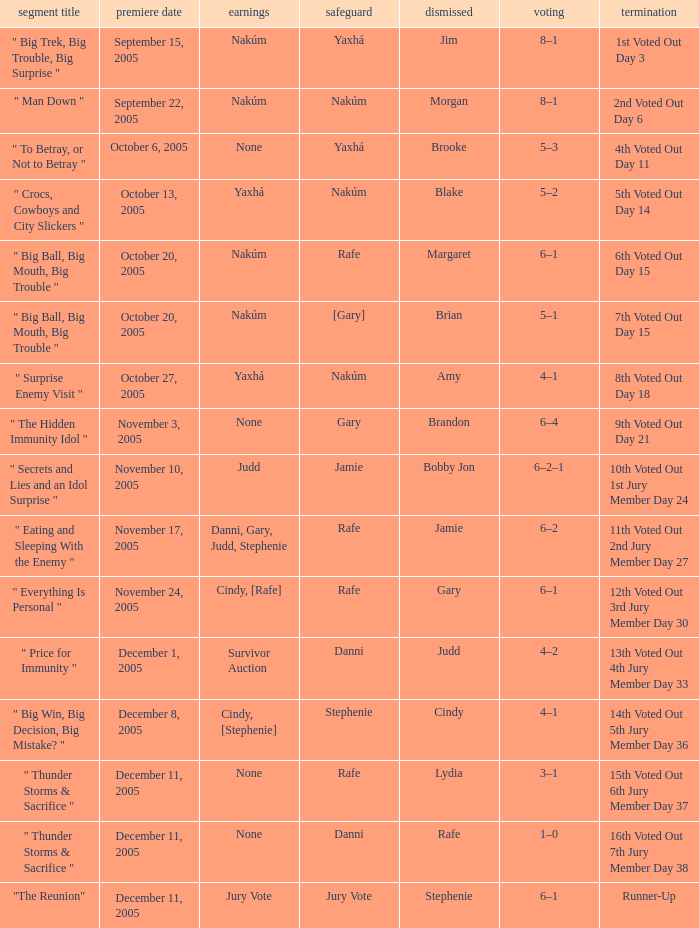What was eliminated on the air date of November 3, 2005? Brandon. 